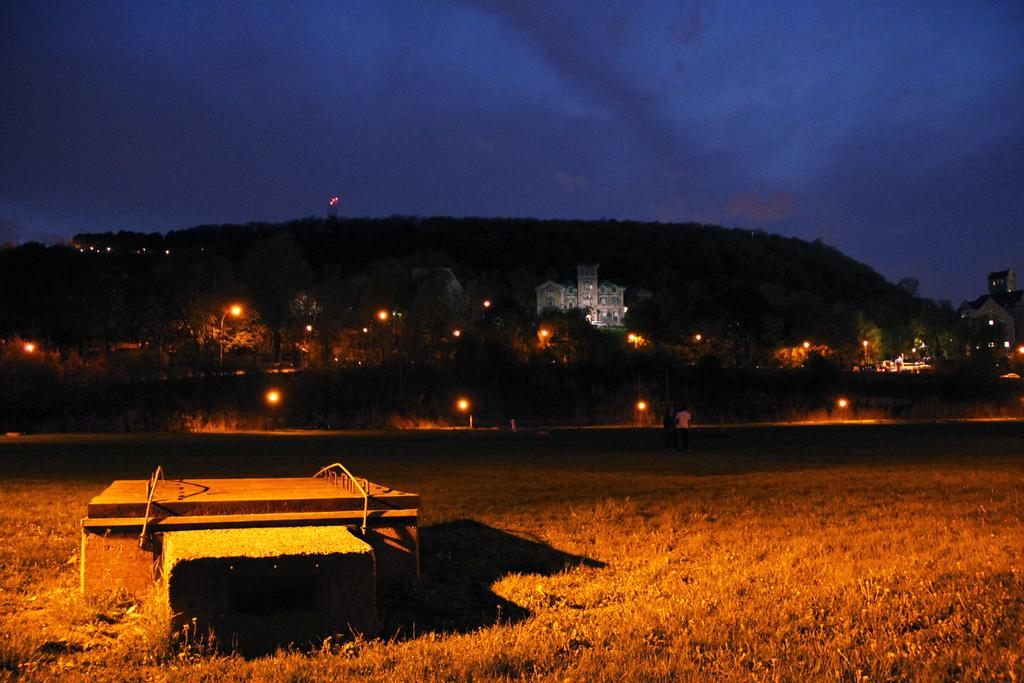What is the main object in the image? There is a table in the image. Where is the table located? The table is placed on the grass. What can be seen in the background of the image? There are buildings, trees, and lights on a hill visible in the background of the image. What type of rake is being used to create the scene in the image? There is no rake present in the image, and no scene is being created. 